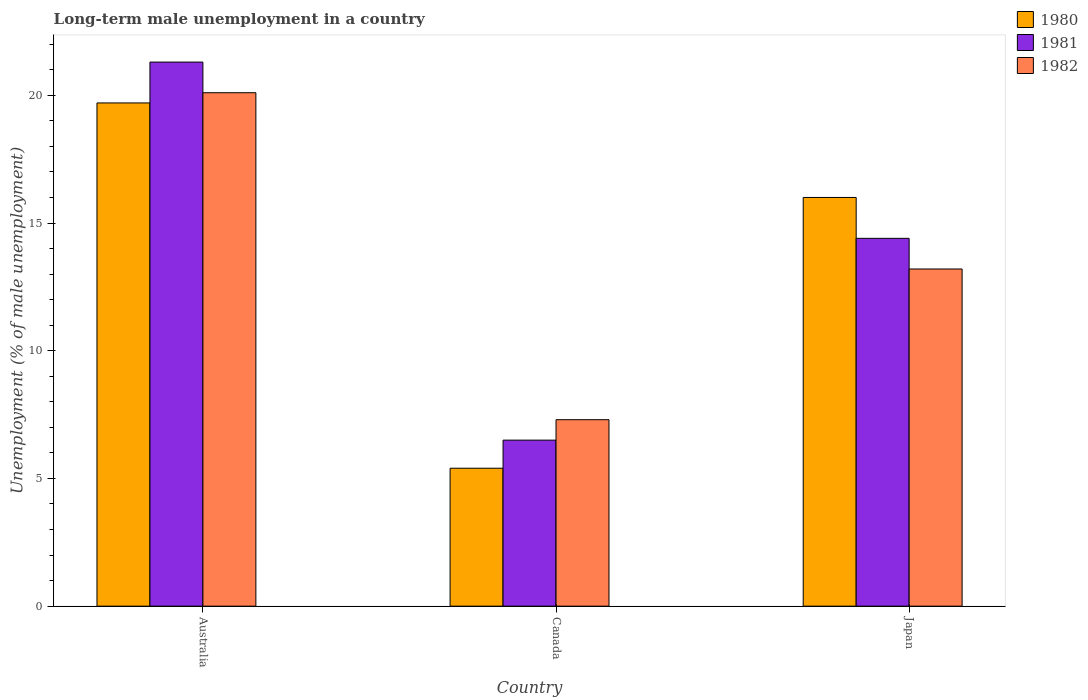How many bars are there on the 1st tick from the left?
Provide a short and direct response. 3. How many bars are there on the 3rd tick from the right?
Offer a very short reply. 3. In how many cases, is the number of bars for a given country not equal to the number of legend labels?
Your response must be concise. 0. What is the percentage of long-term unemployed male population in 1981 in Australia?
Provide a short and direct response. 21.3. Across all countries, what is the maximum percentage of long-term unemployed male population in 1980?
Keep it short and to the point. 19.7. In which country was the percentage of long-term unemployed male population in 1982 maximum?
Provide a short and direct response. Australia. What is the total percentage of long-term unemployed male population in 1981 in the graph?
Ensure brevity in your answer.  42.2. What is the difference between the percentage of long-term unemployed male population in 1982 in Australia and that in Canada?
Offer a very short reply. 12.8. What is the difference between the percentage of long-term unemployed male population in 1980 in Canada and the percentage of long-term unemployed male population in 1982 in Japan?
Keep it short and to the point. -7.8. What is the average percentage of long-term unemployed male population in 1980 per country?
Offer a very short reply. 13.7. What is the difference between the percentage of long-term unemployed male population of/in 1981 and percentage of long-term unemployed male population of/in 1982 in Australia?
Keep it short and to the point. 1.2. In how many countries, is the percentage of long-term unemployed male population in 1980 greater than 16 %?
Make the answer very short. 1. What is the ratio of the percentage of long-term unemployed male population in 1982 in Australia to that in Japan?
Offer a terse response. 1.52. Is the percentage of long-term unemployed male population in 1982 in Australia less than that in Japan?
Make the answer very short. No. Is the difference between the percentage of long-term unemployed male population in 1981 in Australia and Japan greater than the difference between the percentage of long-term unemployed male population in 1982 in Australia and Japan?
Provide a short and direct response. No. What is the difference between the highest and the second highest percentage of long-term unemployed male population in 1980?
Your answer should be very brief. -3.7. What is the difference between the highest and the lowest percentage of long-term unemployed male population in 1980?
Offer a terse response. 14.3. What does the 2nd bar from the left in Australia represents?
Ensure brevity in your answer.  1981. What does the 1st bar from the right in Japan represents?
Make the answer very short. 1982. Is it the case that in every country, the sum of the percentage of long-term unemployed male population in 1980 and percentage of long-term unemployed male population in 1982 is greater than the percentage of long-term unemployed male population in 1981?
Your answer should be compact. Yes. How many countries are there in the graph?
Give a very brief answer. 3. Are the values on the major ticks of Y-axis written in scientific E-notation?
Provide a succinct answer. No. Does the graph contain grids?
Offer a terse response. No. How many legend labels are there?
Your answer should be very brief. 3. How are the legend labels stacked?
Offer a very short reply. Vertical. What is the title of the graph?
Ensure brevity in your answer.  Long-term male unemployment in a country. What is the label or title of the Y-axis?
Offer a terse response. Unemployment (% of male unemployment). What is the Unemployment (% of male unemployment) of 1980 in Australia?
Offer a terse response. 19.7. What is the Unemployment (% of male unemployment) in 1981 in Australia?
Ensure brevity in your answer.  21.3. What is the Unemployment (% of male unemployment) of 1982 in Australia?
Offer a very short reply. 20.1. What is the Unemployment (% of male unemployment) in 1980 in Canada?
Offer a very short reply. 5.4. What is the Unemployment (% of male unemployment) in 1982 in Canada?
Your response must be concise. 7.3. What is the Unemployment (% of male unemployment) in 1981 in Japan?
Provide a succinct answer. 14.4. What is the Unemployment (% of male unemployment) of 1982 in Japan?
Provide a succinct answer. 13.2. Across all countries, what is the maximum Unemployment (% of male unemployment) of 1980?
Give a very brief answer. 19.7. Across all countries, what is the maximum Unemployment (% of male unemployment) in 1981?
Give a very brief answer. 21.3. Across all countries, what is the maximum Unemployment (% of male unemployment) of 1982?
Your answer should be very brief. 20.1. Across all countries, what is the minimum Unemployment (% of male unemployment) in 1980?
Your response must be concise. 5.4. Across all countries, what is the minimum Unemployment (% of male unemployment) in 1982?
Provide a succinct answer. 7.3. What is the total Unemployment (% of male unemployment) of 1980 in the graph?
Keep it short and to the point. 41.1. What is the total Unemployment (% of male unemployment) in 1981 in the graph?
Your answer should be very brief. 42.2. What is the total Unemployment (% of male unemployment) of 1982 in the graph?
Offer a terse response. 40.6. What is the difference between the Unemployment (% of male unemployment) in 1980 in Australia and that in Canada?
Your answer should be compact. 14.3. What is the difference between the Unemployment (% of male unemployment) in 1982 in Australia and that in Japan?
Provide a short and direct response. 6.9. What is the difference between the Unemployment (% of male unemployment) of 1981 in Canada and that in Japan?
Your response must be concise. -7.9. What is the difference between the Unemployment (% of male unemployment) of 1982 in Canada and that in Japan?
Provide a short and direct response. -5.9. What is the difference between the Unemployment (% of male unemployment) in 1980 in Australia and the Unemployment (% of male unemployment) in 1981 in Canada?
Give a very brief answer. 13.2. What is the difference between the Unemployment (% of male unemployment) of 1981 in Australia and the Unemployment (% of male unemployment) of 1982 in Japan?
Your response must be concise. 8.1. What is the difference between the Unemployment (% of male unemployment) of 1980 in Canada and the Unemployment (% of male unemployment) of 1982 in Japan?
Ensure brevity in your answer.  -7.8. What is the difference between the Unemployment (% of male unemployment) in 1981 in Canada and the Unemployment (% of male unemployment) in 1982 in Japan?
Your answer should be compact. -6.7. What is the average Unemployment (% of male unemployment) of 1981 per country?
Make the answer very short. 14.07. What is the average Unemployment (% of male unemployment) of 1982 per country?
Provide a succinct answer. 13.53. What is the difference between the Unemployment (% of male unemployment) in 1980 and Unemployment (% of male unemployment) in 1981 in Australia?
Keep it short and to the point. -1.6. What is the difference between the Unemployment (% of male unemployment) of 1980 and Unemployment (% of male unemployment) of 1982 in Canada?
Provide a short and direct response. -1.9. What is the difference between the Unemployment (% of male unemployment) in 1980 and Unemployment (% of male unemployment) in 1982 in Japan?
Your answer should be very brief. 2.8. What is the difference between the Unemployment (% of male unemployment) of 1981 and Unemployment (% of male unemployment) of 1982 in Japan?
Provide a succinct answer. 1.2. What is the ratio of the Unemployment (% of male unemployment) in 1980 in Australia to that in Canada?
Offer a very short reply. 3.65. What is the ratio of the Unemployment (% of male unemployment) of 1981 in Australia to that in Canada?
Your answer should be compact. 3.28. What is the ratio of the Unemployment (% of male unemployment) of 1982 in Australia to that in Canada?
Provide a succinct answer. 2.75. What is the ratio of the Unemployment (% of male unemployment) of 1980 in Australia to that in Japan?
Keep it short and to the point. 1.23. What is the ratio of the Unemployment (% of male unemployment) in 1981 in Australia to that in Japan?
Keep it short and to the point. 1.48. What is the ratio of the Unemployment (% of male unemployment) in 1982 in Australia to that in Japan?
Make the answer very short. 1.52. What is the ratio of the Unemployment (% of male unemployment) of 1980 in Canada to that in Japan?
Provide a succinct answer. 0.34. What is the ratio of the Unemployment (% of male unemployment) of 1981 in Canada to that in Japan?
Your answer should be very brief. 0.45. What is the ratio of the Unemployment (% of male unemployment) of 1982 in Canada to that in Japan?
Provide a short and direct response. 0.55. What is the difference between the highest and the lowest Unemployment (% of male unemployment) of 1980?
Keep it short and to the point. 14.3. What is the difference between the highest and the lowest Unemployment (% of male unemployment) of 1981?
Your answer should be compact. 14.8. What is the difference between the highest and the lowest Unemployment (% of male unemployment) of 1982?
Give a very brief answer. 12.8. 